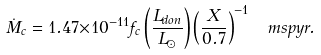Convert formula to latex. <formula><loc_0><loc_0><loc_500><loc_500>\dot { M } _ { c } = 1 . 4 7 { \times } 1 0 ^ { - 1 1 } f _ { c } \left ( \frac { L _ { d o n } } { L _ { \odot } } \right ) \left ( \frac { X } { 0 . 7 } \right ) ^ { - 1 } \, \ m s p y r .</formula> 